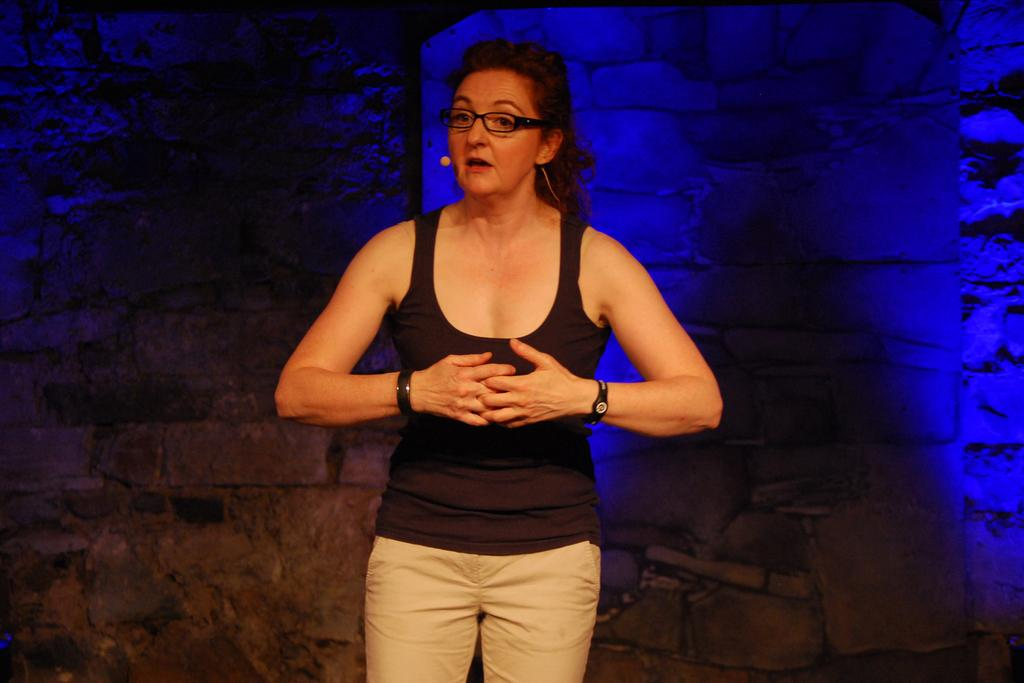What is the main subject of the image? There is a person in the image. What is the person doing in the image? The person is standing. What color is the shirt the person is wearing? The person is wearing a black shirt. What color are the pants the person is wearing? The person is wearing cream pants. What can be seen in the background of the image? There is a wall in the background of the image. Can you see any wilderness or volcanoes in the image? No, there is no wilderness or volcanoes present in the image. Are there any bees buzzing around the person in the image? No, there are no bees visible in the image. 